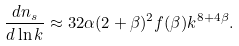<formula> <loc_0><loc_0><loc_500><loc_500>\frac { d n _ { s } } { d \ln k } \approx { 3 2 \alpha ( 2 + \beta ) ^ { 2 } f ( \beta ) k ^ { 8 + 4 \beta } } .</formula> 